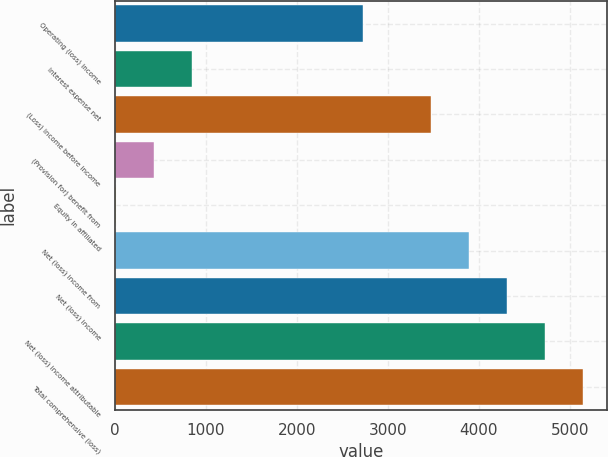Convert chart. <chart><loc_0><loc_0><loc_500><loc_500><bar_chart><fcel>Operating (loss) income<fcel>Interest expense net<fcel>(Loss) income before income<fcel>(Provision for) benefit from<fcel>Equity in affiliated<fcel>Net (loss) income from<fcel>Net (loss) income<fcel>Net (loss) income attributable<fcel>Total comprehensive (loss)<nl><fcel>2729<fcel>848.6<fcel>3472<fcel>429.8<fcel>11<fcel>3890.8<fcel>4309.6<fcel>4728.4<fcel>5147.2<nl></chart> 